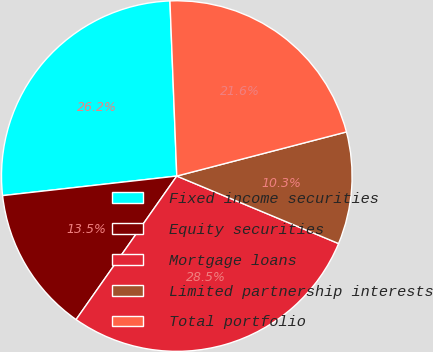Convert chart. <chart><loc_0><loc_0><loc_500><loc_500><pie_chart><fcel>Fixed income securities<fcel>Equity securities<fcel>Mortgage loans<fcel>Limited partnership interests<fcel>Total portfolio<nl><fcel>26.16%<fcel>13.48%<fcel>28.45%<fcel>10.34%<fcel>21.57%<nl></chart> 